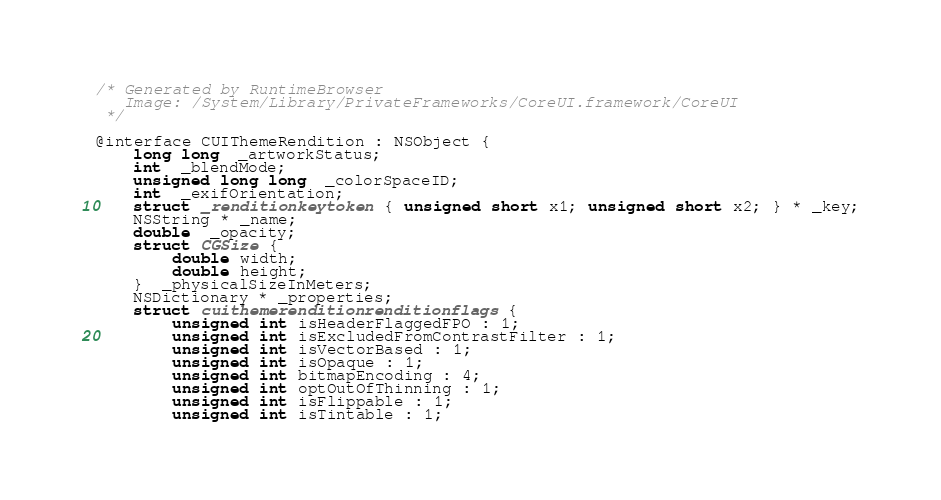<code> <loc_0><loc_0><loc_500><loc_500><_C_>/* Generated by RuntimeBrowser
   Image: /System/Library/PrivateFrameworks/CoreUI.framework/CoreUI
 */

@interface CUIThemeRendition : NSObject {
    long long  _artworkStatus;
    int  _blendMode;
    unsigned long long  _colorSpaceID;
    int  _exifOrientation;
    struct _renditionkeytoken { unsigned short x1; unsigned short x2; } * _key;
    NSString * _name;
    double  _opacity;
    struct CGSize { 
        double width; 
        double height; 
    }  _physicalSizeInMeters;
    NSDictionary * _properties;
    struct cuithemerenditionrenditionflags { 
        unsigned int isHeaderFlaggedFPO : 1; 
        unsigned int isExcludedFromContrastFilter : 1; 
        unsigned int isVectorBased : 1; 
        unsigned int isOpaque : 1; 
        unsigned int bitmapEncoding : 4; 
        unsigned int optOutOfThinning : 1; 
        unsigned int isFlippable : 1; 
        unsigned int isTintable : 1; </code> 